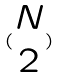<formula> <loc_0><loc_0><loc_500><loc_500>( \begin{matrix} N \\ 2 \end{matrix} )</formula> 